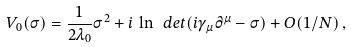<formula> <loc_0><loc_0><loc_500><loc_500>V _ { 0 } ( \sigma ) = \frac { 1 } { 2 \lambda _ { 0 } } \sigma ^ { 2 } + i \, \ln \ d e t ( i \gamma _ { \mu } \partial ^ { \mu } - \sigma ) + O ( 1 / N ) \, ,</formula> 